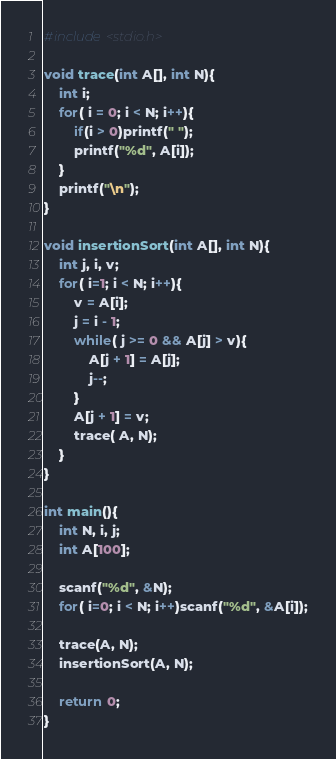Convert code to text. <code><loc_0><loc_0><loc_500><loc_500><_C_>#include<stdio.h>

void trace(int A[], int N){
    int i;
    for( i = 0; i < N; i++){
        if(i > 0)printf(" ");
        printf("%d", A[i]);
    }
    printf("\n");
}

void insertionSort(int A[], int N){
    int j, i, v;
    for( i=1; i < N; i++){
        v = A[i];
        j = i - 1;
        while( j >= 0 && A[j] > v){
            A[j + 1] = A[j];
            j--;
        }
        A[j + 1] = v;
        trace( A, N);
    }
}

int main(){
    int N, i, j;
    int A[100];

    scanf("%d", &N);
    for( i=0; i < N; i++)scanf("%d", &A[i]);

    trace(A, N);
    insertionSort(A, N);

    return 0;
}
</code> 